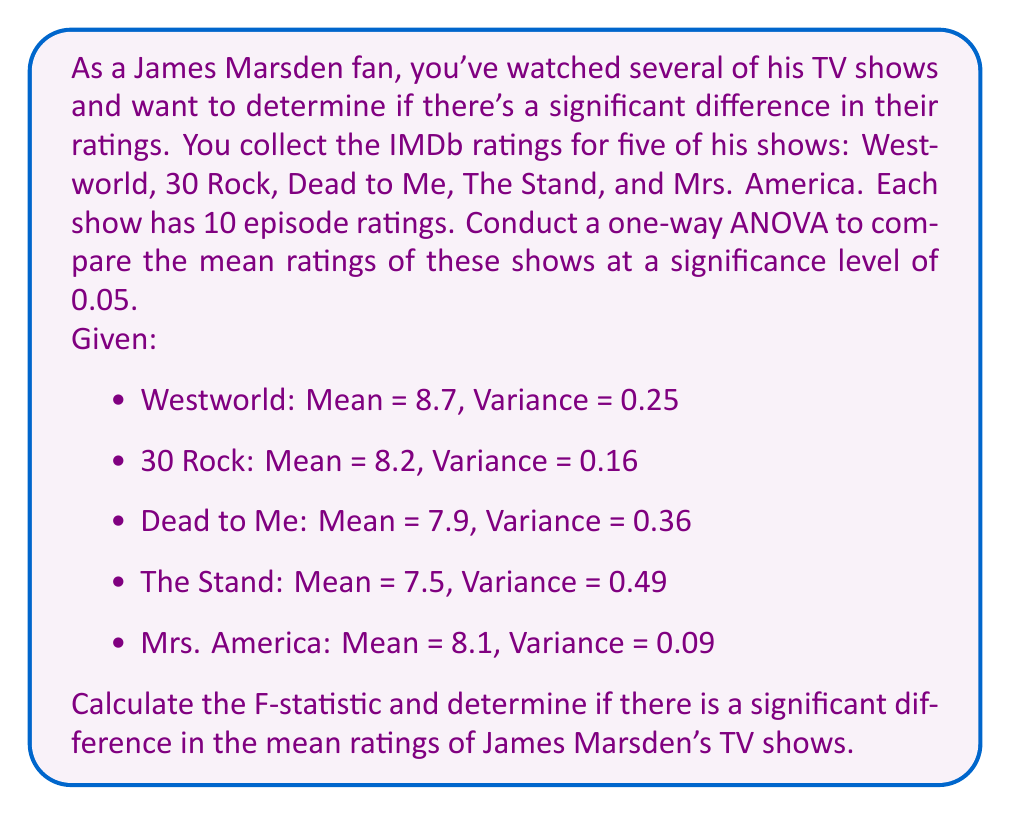Show me your answer to this math problem. To conduct a one-way ANOVA, we'll follow these steps:

1. Calculate the overall mean:
$$\bar{X} = \frac{8.7 + 8.2 + 7.9 + 7.5 + 8.1}{5} = 8.08$$

2. Calculate SSB (Sum of Squares Between groups):
$$SSB = \sum_{i=1}^{k} n_i(\bar{X_i} - \bar{X})^2$$
$$SSB = 10[(8.7 - 8.08)^2 + (8.2 - 8.08)^2 + (7.9 - 8.08)^2 + (7.5 - 8.08)^2 + (8.1 - 8.08)^2]$$
$$SSB = 10(0.3844 + 0.0144 + 0.0324 + 0.3364 + 0.0004) = 7.68$$

3. Calculate SSW (Sum of Squares Within groups):
$$SSW = \sum_{i=1}^{k} (n_i - 1)s_i^2$$
$$SSW = 9(0.25 + 0.16 + 0.36 + 0.49 + 0.09) = 12.15$$

4. Calculate degrees of freedom:
$$df_{between} = k - 1 = 5 - 1 = 4$$
$$df_{within} = N - k = 50 - 5 = 45$$

5. Calculate Mean Square Between (MSB) and Mean Square Within (MSW):
$$MSB = \frac{SSB}{df_{between}} = \frac{7.68}{4} = 1.92$$
$$MSW = \frac{SSW}{df_{within}} = \frac{12.15}{45} = 0.27$$

6. Calculate the F-statistic:
$$F = \frac{MSB}{MSW} = \frac{1.92}{0.27} = 7.11$$

7. Determine the critical F-value:
At α = 0.05, with df₁ = 4 and df₂ = 45, the critical F-value is approximately 2.58.

8. Compare the F-statistic to the critical F-value:
Since 7.11 > 2.58, we reject the null hypothesis.
Answer: The F-statistic is 7.11, which is greater than the critical F-value of 2.58. Therefore, we reject the null hypothesis and conclude that there is a significant difference in the mean ratings of James Marsden's TV shows at the 0.05 significance level. 